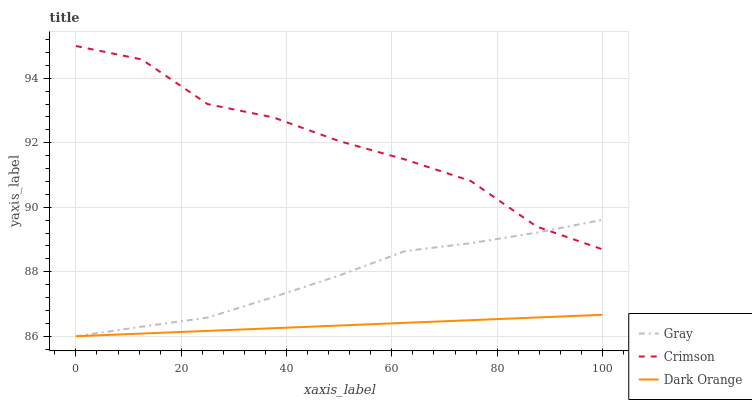Does Dark Orange have the minimum area under the curve?
Answer yes or no. Yes. Does Crimson have the maximum area under the curve?
Answer yes or no. Yes. Does Gray have the minimum area under the curve?
Answer yes or no. No. Does Gray have the maximum area under the curve?
Answer yes or no. No. Is Dark Orange the smoothest?
Answer yes or no. Yes. Is Crimson the roughest?
Answer yes or no. Yes. Is Gray the smoothest?
Answer yes or no. No. Is Gray the roughest?
Answer yes or no. No. Does Gray have the lowest value?
Answer yes or no. Yes. Does Crimson have the highest value?
Answer yes or no. Yes. Does Gray have the highest value?
Answer yes or no. No. Is Dark Orange less than Crimson?
Answer yes or no. Yes. Is Crimson greater than Dark Orange?
Answer yes or no. Yes. Does Gray intersect Crimson?
Answer yes or no. Yes. Is Gray less than Crimson?
Answer yes or no. No. Is Gray greater than Crimson?
Answer yes or no. No. Does Dark Orange intersect Crimson?
Answer yes or no. No. 